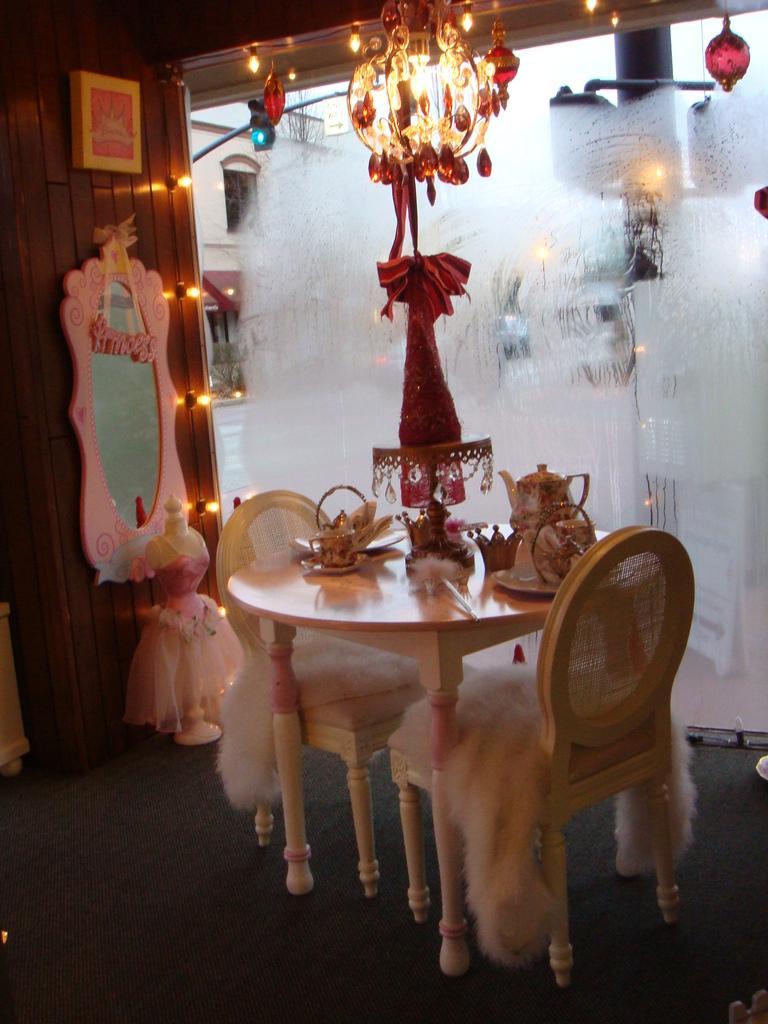Can you describe this image briefly? In this image I can see the table and two chairs and I can see few objects on the table. In the background I can see the glass wall, the mirror attached to the wooden wall and I can see few lights and the chandelier and the sky is in white color. 